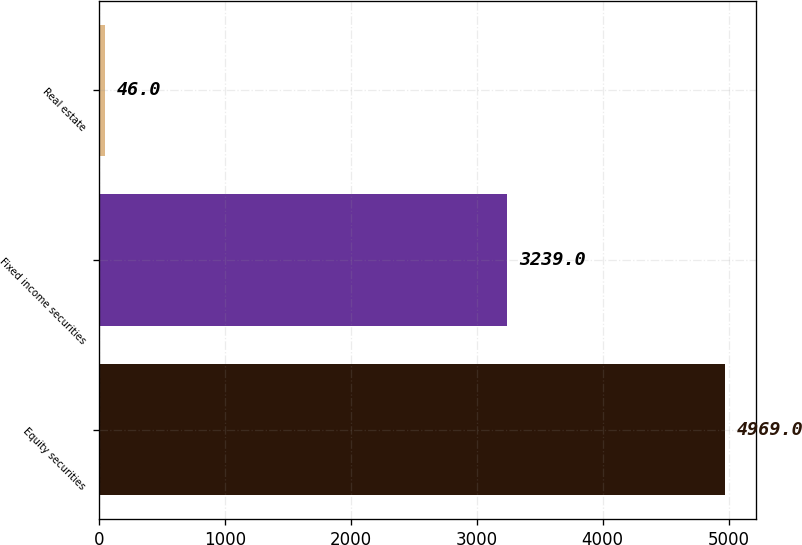Convert chart. <chart><loc_0><loc_0><loc_500><loc_500><bar_chart><fcel>Equity securities<fcel>Fixed income securities<fcel>Real estate<nl><fcel>4969<fcel>3239<fcel>46<nl></chart> 